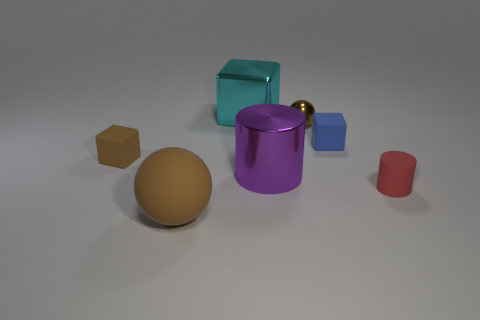Is the color of the rubber object in front of the tiny red thing the same as the small shiny thing?
Ensure brevity in your answer.  Yes. What number of other objects are the same color as the large ball?
Keep it short and to the point. 2. What number of objects are either brown objects or red objects?
Provide a succinct answer. 4. What number of objects are either tiny cylinders or cyan shiny things behind the big brown ball?
Ensure brevity in your answer.  2. Is the material of the cyan thing the same as the large cylinder?
Provide a short and direct response. Yes. What number of other things are there of the same material as the big block
Your response must be concise. 2. Are there more big brown cubes than blue matte things?
Provide a succinct answer. No. Does the small thing on the left side of the big sphere have the same shape as the large cyan shiny object?
Your response must be concise. Yes. Are there fewer small gray metallic cubes than cyan things?
Provide a succinct answer. Yes. There is a brown thing that is the same size as the shiny cylinder; what is it made of?
Your response must be concise. Rubber. 